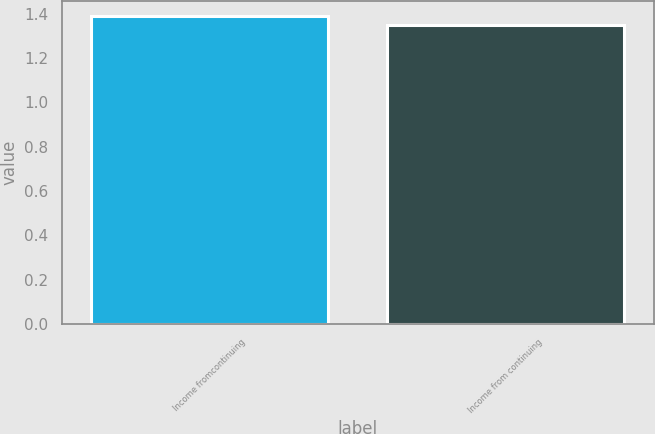<chart> <loc_0><loc_0><loc_500><loc_500><bar_chart><fcel>Income fromcontinuing<fcel>Income from continuing<nl><fcel>1.39<fcel>1.35<nl></chart> 